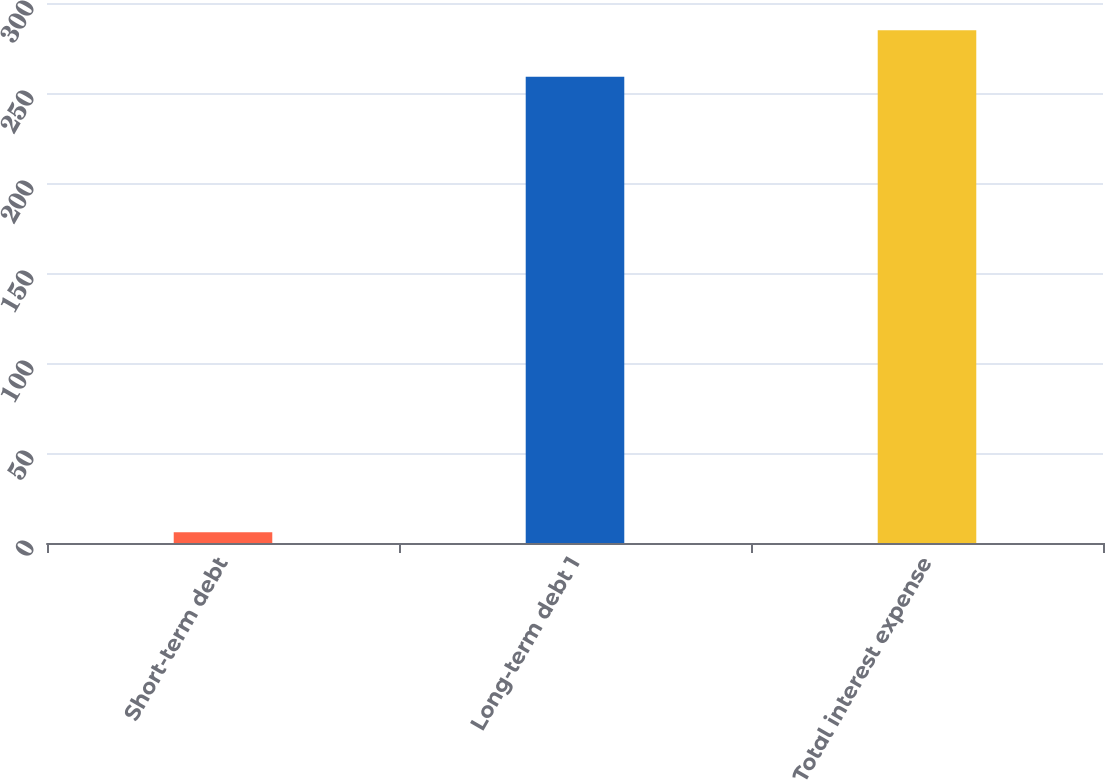Convert chart to OTSL. <chart><loc_0><loc_0><loc_500><loc_500><bar_chart><fcel>Short-term debt<fcel>Long-term debt 1<fcel>Total interest expense<nl><fcel>6<fcel>259<fcel>284.9<nl></chart> 